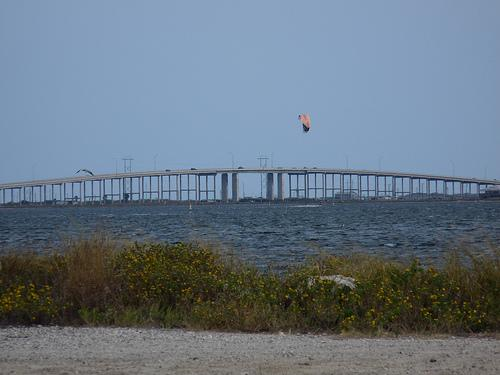Provide a poetic description of the image. Amidst the tranquil waters lies a bridge, embracing the sky so blue, and cheerful yellow flowers blooming anew. Explain the weather conditions seen in the image. The weather in the image is sunny with a clear blue sky. Create a sentence that combines three objects featured in the image. Yellow flowers flourish near the serene body of water as the parasail glides across the clear blue sky. Express in one sentence the interaction of flora and water in the image. Yellow flowers growing nearby create a pleasant contrast to the calm water and the sandy bank. Indicate the main setting of the image. The image is set near a calm body of water with a bridge. Mention the primary object and its color in the image. Yellow flowers are the prominent object in the image. Identify and describe the man-made structure in the image. There is a long bridge above the calm body of water in the image. Write a brief description of the scene in the image. The image depicts yellow flowers, a calm body of water, a blue sky, and a long bridge. Describe the most engaging aspect of the image. The clear blue sky and yellow flowers present a striking visual, illuminating the serene body of water and bridge. List the key elements present in the image. Yellow flowers, bridge, body of water, sunny weather, blue sky, parasail, stones, sand, and ripples. 